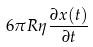<formula> <loc_0><loc_0><loc_500><loc_500>6 \pi R \eta \frac { \partial x ( t ) } { \partial t }</formula> 